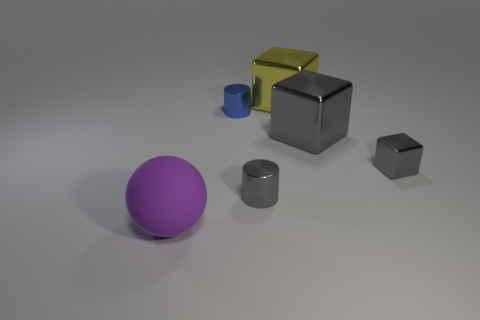Add 1 big red shiny balls. How many objects exist? 7 Subtract all cylinders. How many objects are left? 4 Add 5 tiny gray cylinders. How many tiny gray cylinders are left? 6 Add 1 big yellow objects. How many big yellow objects exist? 2 Subtract 0 cyan spheres. How many objects are left? 6 Subtract all big rubber balls. Subtract all small things. How many objects are left? 2 